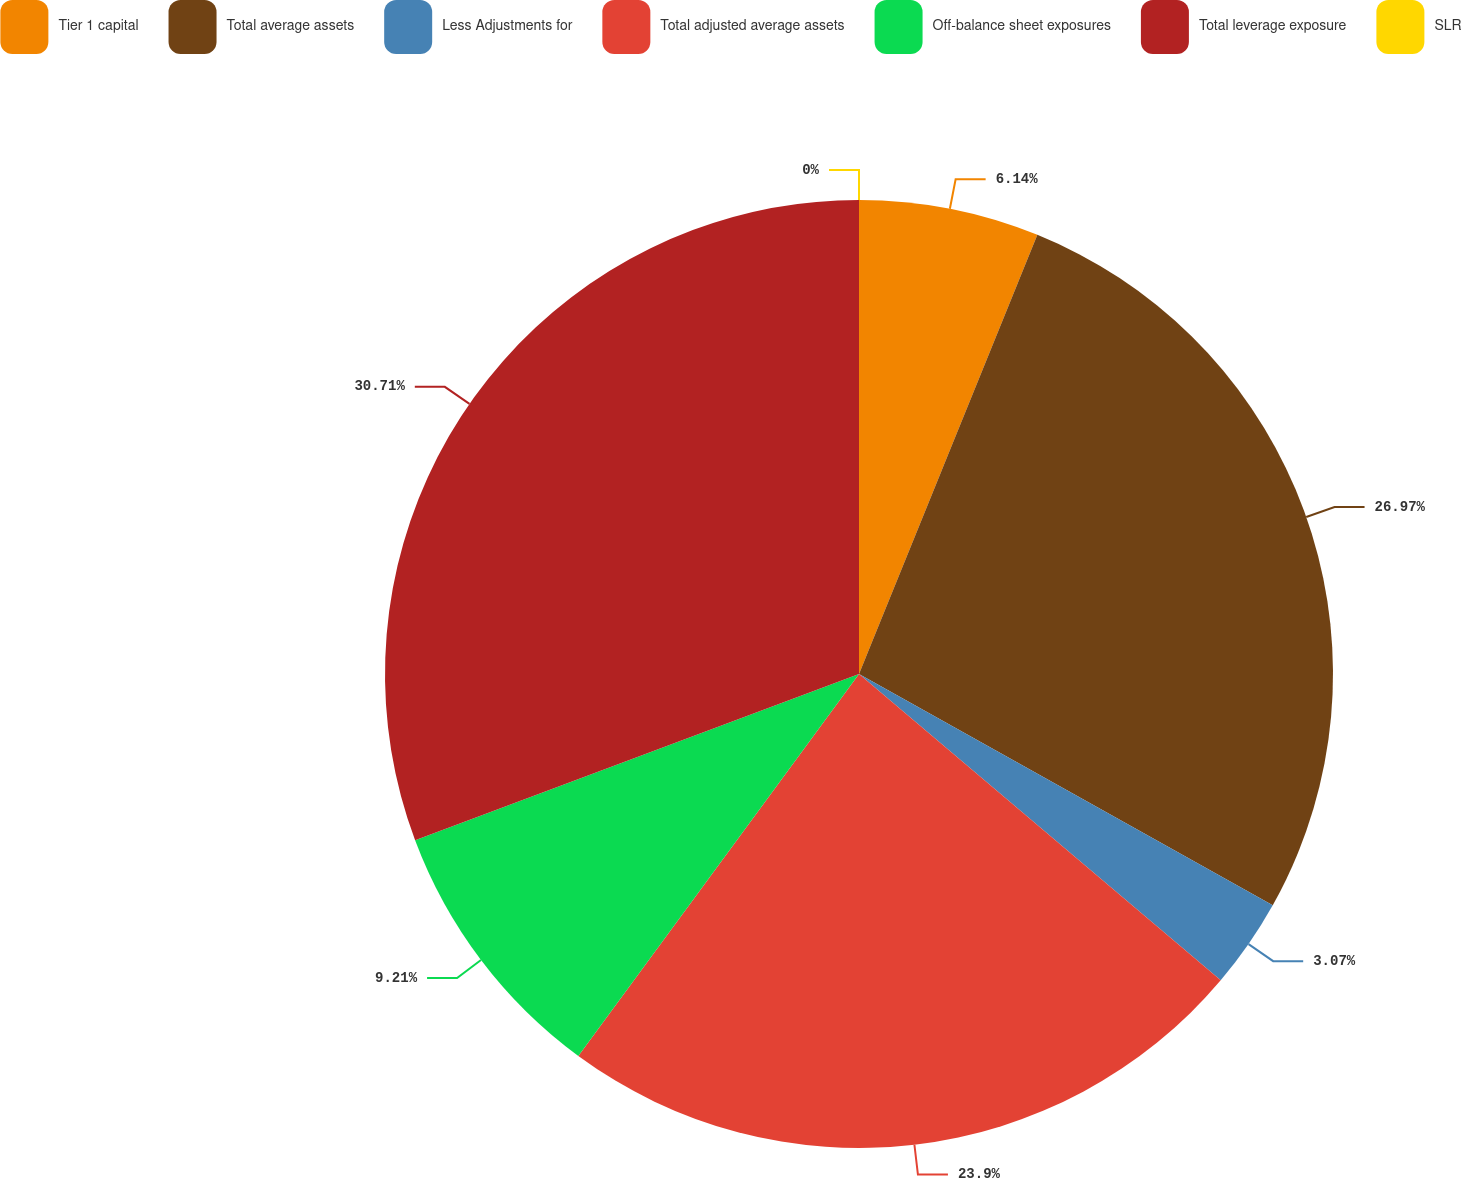<chart> <loc_0><loc_0><loc_500><loc_500><pie_chart><fcel>Tier 1 capital<fcel>Total average assets<fcel>Less Adjustments for<fcel>Total adjusted average assets<fcel>Off-balance sheet exposures<fcel>Total leverage exposure<fcel>SLR<nl><fcel>6.14%<fcel>26.97%<fcel>3.07%<fcel>23.9%<fcel>9.21%<fcel>30.7%<fcel>0.0%<nl></chart> 